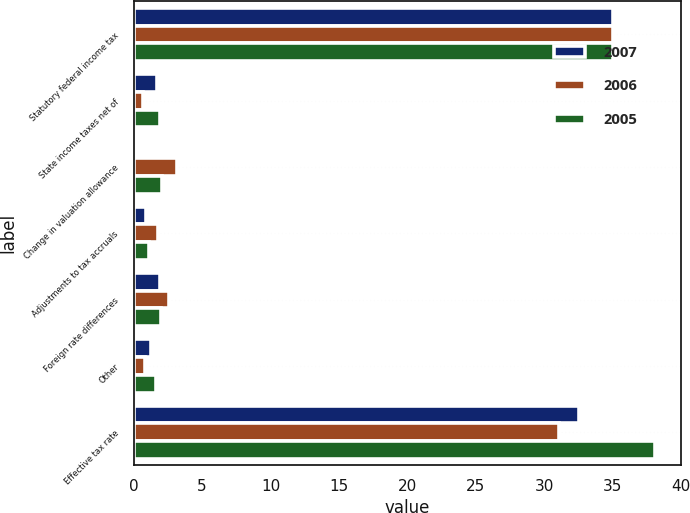<chart> <loc_0><loc_0><loc_500><loc_500><stacked_bar_chart><ecel><fcel>Statutory federal income tax<fcel>State income taxes net of<fcel>Change in valuation allowance<fcel>Adjustments to tax accruals<fcel>Foreign rate differences<fcel>Other<fcel>Effective tax rate<nl><fcel>2007<fcel>35<fcel>1.7<fcel>0.1<fcel>0.9<fcel>1.9<fcel>1.3<fcel>32.5<nl><fcel>2006<fcel>35<fcel>0.7<fcel>3.2<fcel>1.8<fcel>2.6<fcel>0.8<fcel>31.1<nl><fcel>2005<fcel>35<fcel>1.9<fcel>2.1<fcel>1.1<fcel>2<fcel>1.6<fcel>38.1<nl></chart> 